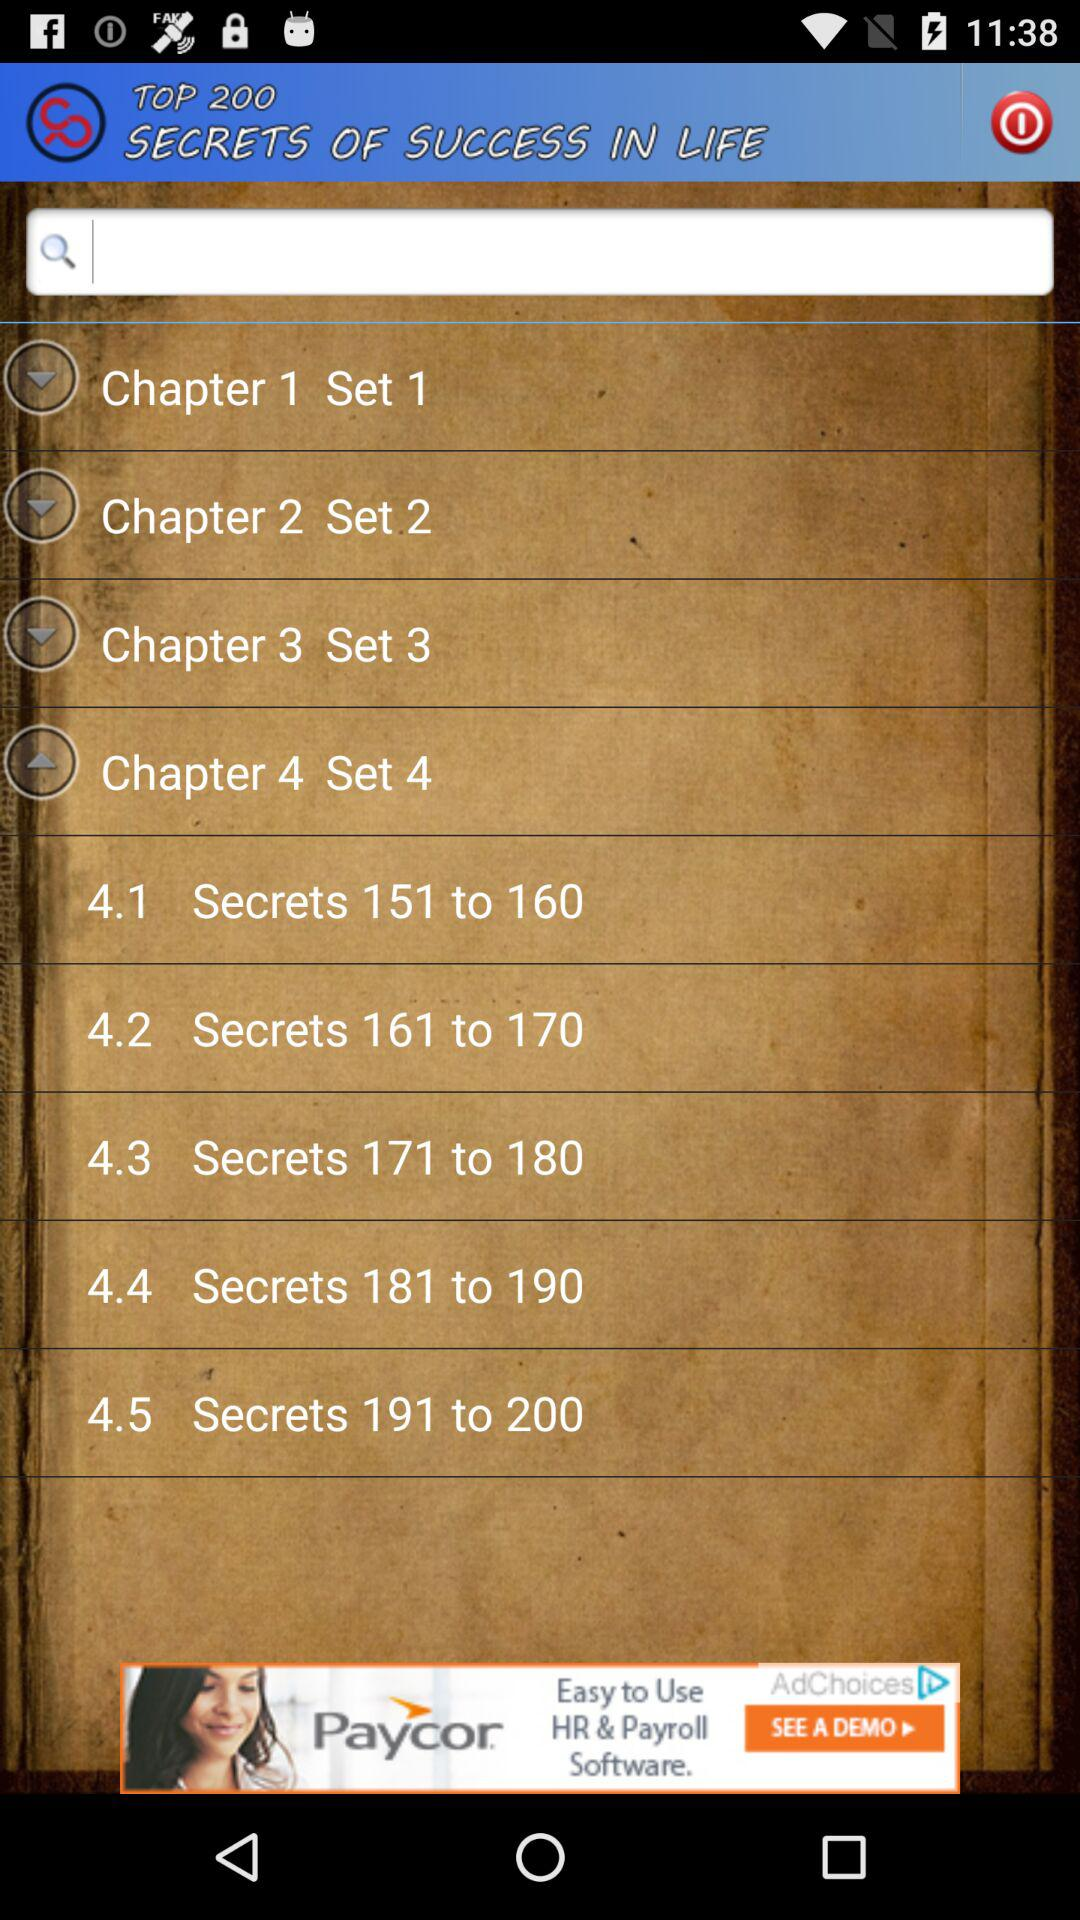How many secrets are in chapter 4?
Answer the question using a single word or phrase. 50 